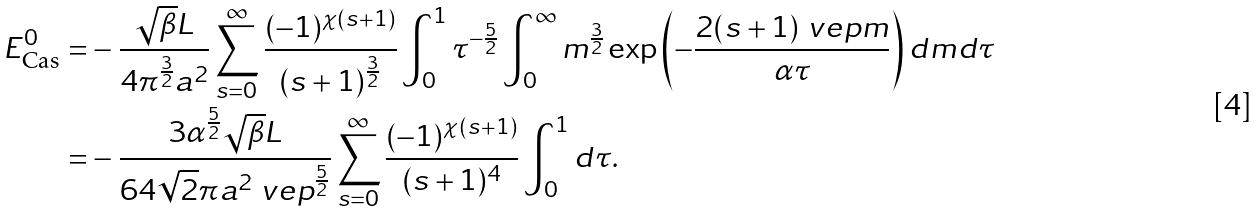<formula> <loc_0><loc_0><loc_500><loc_500>E _ { \text {Cas} } ^ { 0 } = & - \frac { \sqrt { \beta } L } { 4 \pi ^ { \frac { 3 } { 2 } } a ^ { 2 } } \sum _ { s = 0 } ^ { \infty } \frac { ( - 1 ) ^ { \chi ( s + 1 ) } } { ( s + 1 ) ^ { \frac { 3 } { 2 } } } \int _ { 0 } ^ { 1 } \tau ^ { - \frac { 5 } { 2 } } \int _ { 0 } ^ { \infty } m ^ { \frac { 3 } { 2 } } \exp \left ( - \frac { 2 ( s + 1 ) \ v e p m } { \alpha \tau } \right ) d m d \tau \\ = & - \frac { 3 \alpha ^ { \frac { 5 } { 2 } } \sqrt { \beta } L } { 6 4 \sqrt { 2 } \pi a ^ { 2 } \ v e p ^ { \frac { 5 } { 2 } } } \sum _ { s = 0 } ^ { \infty } \frac { ( - 1 ) ^ { \chi ( s + 1 ) } } { ( s + 1 ) ^ { 4 } } \int _ { 0 } ^ { 1 } d \tau .</formula> 